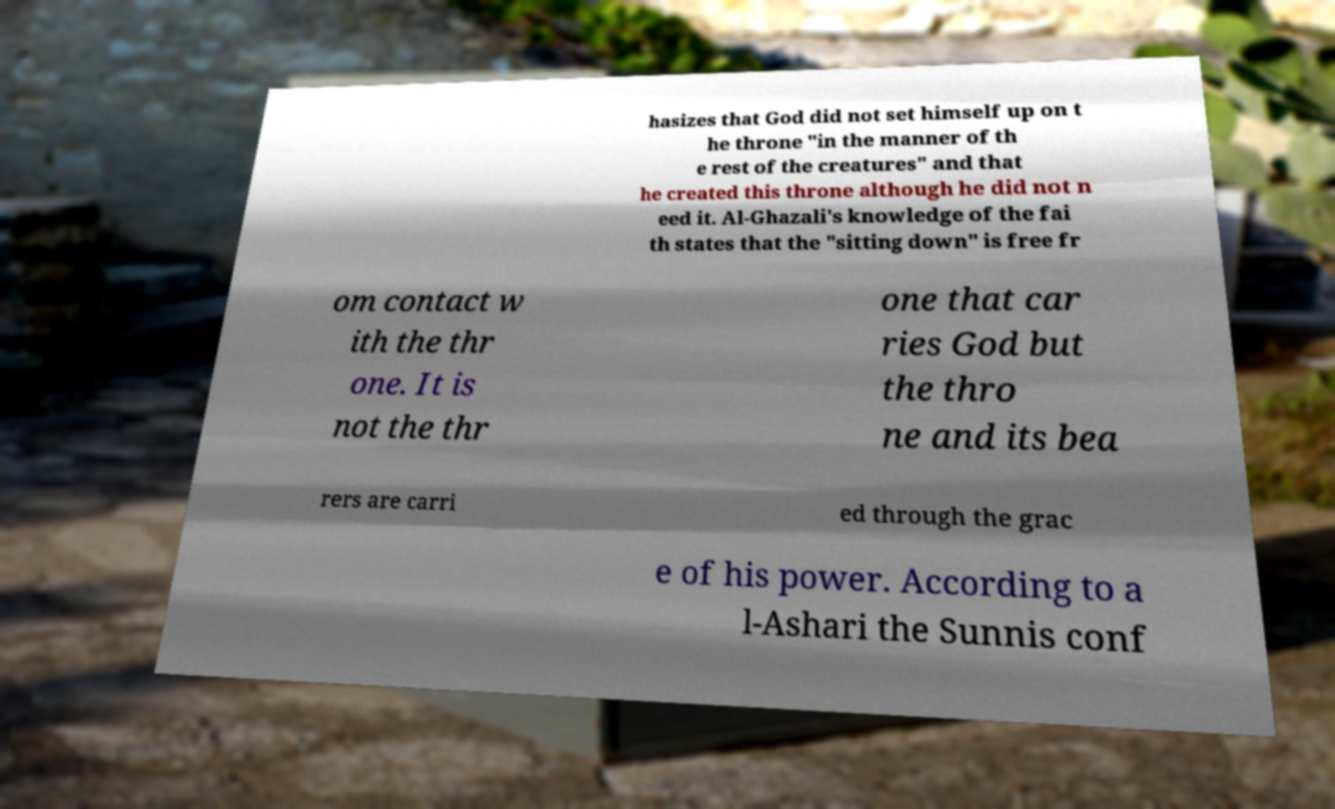For documentation purposes, I need the text within this image transcribed. Could you provide that? hasizes that God did not set himself up on t he throne "in the manner of th e rest of the creatures" and that he created this throne although he did not n eed it. Al-Ghazali's knowledge of the fai th states that the "sitting down" is free fr om contact w ith the thr one. It is not the thr one that car ries God but the thro ne and its bea rers are carri ed through the grac e of his power. According to a l-Ashari the Sunnis conf 